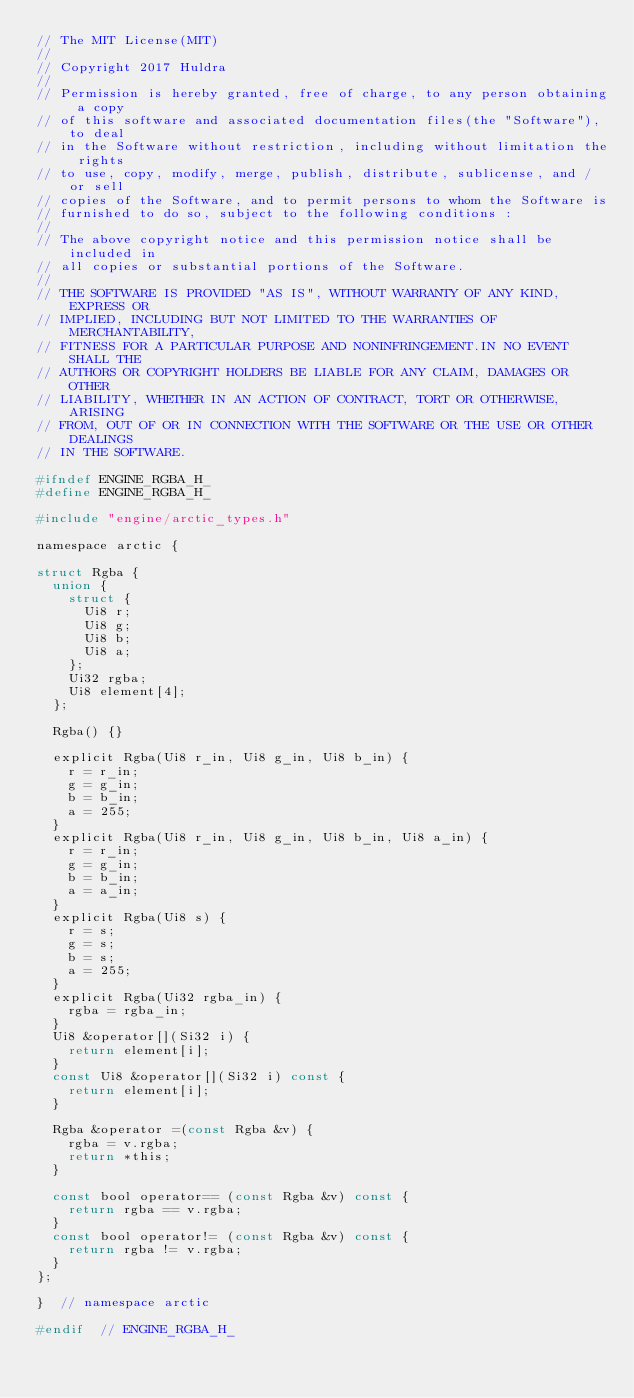Convert code to text. <code><loc_0><loc_0><loc_500><loc_500><_C_>// The MIT License(MIT)
//
// Copyright 2017 Huldra
//
// Permission is hereby granted, free of charge, to any person obtaining a copy
// of this software and associated documentation files(the "Software"), to deal
// in the Software without restriction, including without limitation the rights
// to use, copy, modify, merge, publish, distribute, sublicense, and / or sell
// copies of the Software, and to permit persons to whom the Software is
// furnished to do so, subject to the following conditions :
//
// The above copyright notice and this permission notice shall be included in
// all copies or substantial portions of the Software.
//
// THE SOFTWARE IS PROVIDED "AS IS", WITHOUT WARRANTY OF ANY KIND, EXPRESS OR
// IMPLIED, INCLUDING BUT NOT LIMITED TO THE WARRANTIES OF MERCHANTABILITY,
// FITNESS FOR A PARTICULAR PURPOSE AND NONINFRINGEMENT.IN NO EVENT SHALL THE
// AUTHORS OR COPYRIGHT HOLDERS BE LIABLE FOR ANY CLAIM, DAMAGES OR OTHER
// LIABILITY, WHETHER IN AN ACTION OF CONTRACT, TORT OR OTHERWISE, ARISING
// FROM, OUT OF OR IN CONNECTION WITH THE SOFTWARE OR THE USE OR OTHER DEALINGS
// IN THE SOFTWARE.

#ifndef ENGINE_RGBA_H_
#define ENGINE_RGBA_H_

#include "engine/arctic_types.h"

namespace arctic {

struct Rgba {
  union {
    struct {
      Ui8 r;
      Ui8 g;
      Ui8 b;
      Ui8 a;
    };
    Ui32 rgba;
    Ui8 element[4];
  };

  Rgba() {}

  explicit Rgba(Ui8 r_in, Ui8 g_in, Ui8 b_in) {
    r = r_in;
    g = g_in;
    b = b_in;
    a = 255;
  }
  explicit Rgba(Ui8 r_in, Ui8 g_in, Ui8 b_in, Ui8 a_in) {
    r = r_in;
    g = g_in;
    b = b_in;
    a = a_in;
  }
  explicit Rgba(Ui8 s) {
    r = s;
    g = s;
    b = s;
    a = 255;
  }
  explicit Rgba(Ui32 rgba_in) {
    rgba = rgba_in;
  }
  Ui8 &operator[](Si32 i) {
    return element[i];
  }
  const Ui8 &operator[](Si32 i) const {
    return element[i];
  }

  Rgba &operator =(const Rgba &v) {
    rgba = v.rgba;
    return *this;
  }

  const bool operator== (const Rgba &v) const {
    return rgba == v.rgba;
  }
  const bool operator!= (const Rgba &v) const {
    return rgba != v.rgba;
  }
};

}  // namespace arctic

#endif  // ENGINE_RGBA_H_
</code> 